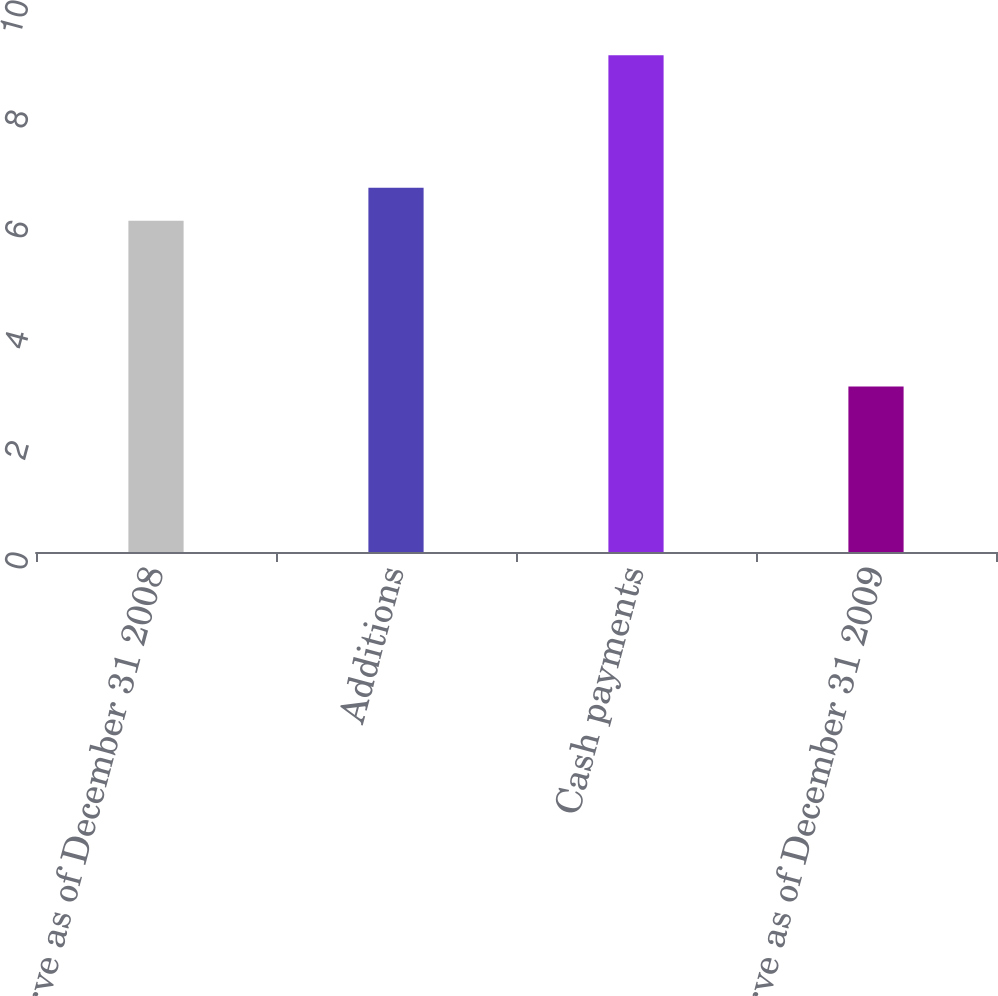Convert chart. <chart><loc_0><loc_0><loc_500><loc_500><bar_chart><fcel>Reserve as of December 31 2008<fcel>Additions<fcel>Cash payments<fcel>Reserve as of December 31 2009<nl><fcel>6<fcel>6.6<fcel>9<fcel>3<nl></chart> 